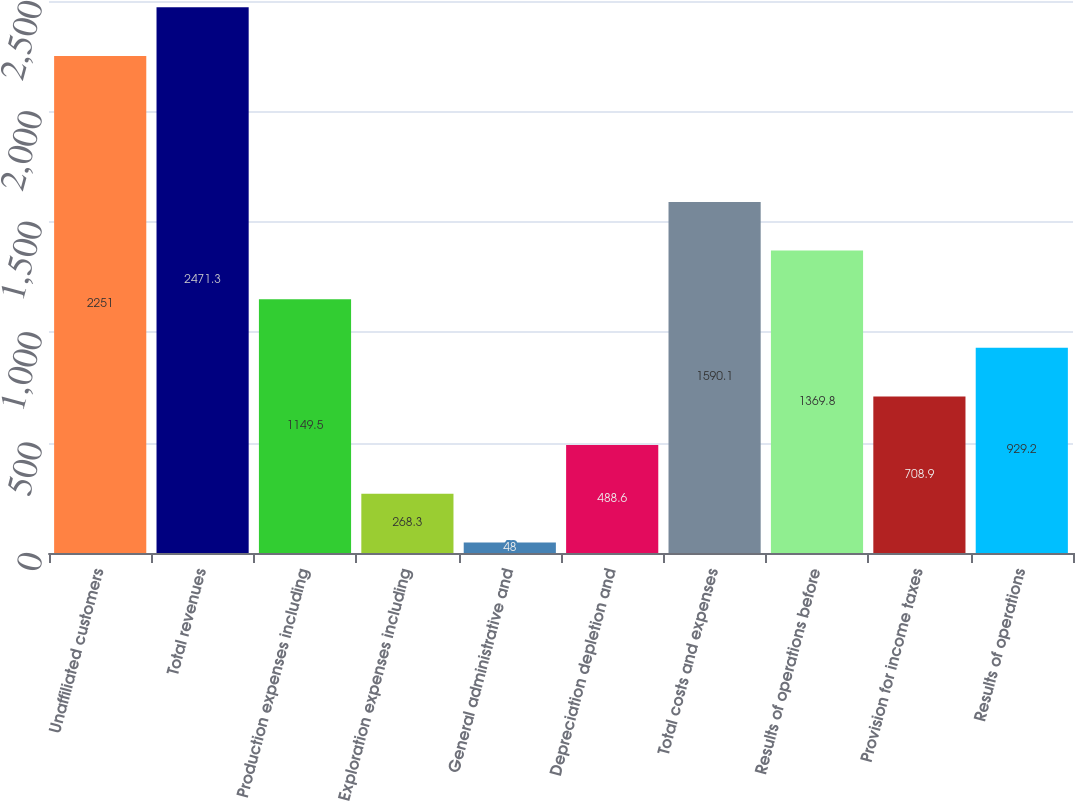<chart> <loc_0><loc_0><loc_500><loc_500><bar_chart><fcel>Unaffiliated customers<fcel>Total revenues<fcel>Production expenses including<fcel>Exploration expenses including<fcel>General administrative and<fcel>Depreciation depletion and<fcel>Total costs and expenses<fcel>Results of operations before<fcel>Provision for income taxes<fcel>Results of operations<nl><fcel>2251<fcel>2471.3<fcel>1149.5<fcel>268.3<fcel>48<fcel>488.6<fcel>1590.1<fcel>1369.8<fcel>708.9<fcel>929.2<nl></chart> 